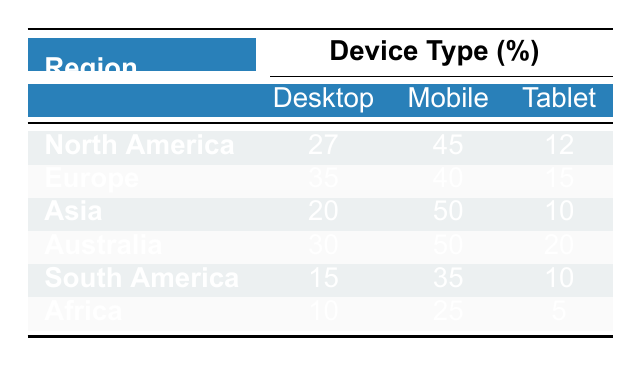What is the percentage of VPN usage for Desktop in Europe? The table shows that the percentage of VPN usage for Desktop in Europe is 35.
Answer: 35 Which region has the highest VPN usage on Mobile devices? By inspecting the table, Asia and Australia both have 50% VPN usage on Mobile devices, which is the highest among all regions.
Answer: Asia and Australia What is the total percentage of VPN usage on Tablets across all regions? Adding the percentages for Tablets from each region gives (12 + 15 + 10 + 20 + 10 + 5) = 72.
Answer: 72 Is South America's VPN usage on Desktop greater than that of Africa? The table indicates that South America has 15% usage on Desktop, while Africa has 10%, meaning South America’s usage is indeed greater.
Answer: Yes What is the difference in VPN usage percentage on Mobile devices between North America and South America? North America has 45% and South America has 35% for Mobile devices. The difference is 45 - 35 = 10.
Answer: 10 What is the average VPN usage percentage for Tablets across all regions? Adding the percentages for Tablets gives (12 + 15 + 10 + 20 + 10 + 5) = 72, and there are 6 regions; thus, the average is 72/6 = 12.
Answer: 12 Which region has the lowest VPN usage on Tablets? By examining the Table for Tablet usage percentages, Africa has the lowest at 5%.
Answer: Africa If you combine the VPN usage percentages for Desktop and Tablet in North America, what is the total? The Desktop percentage is 27% and the Tablet percentage is 12%. Therefore, the total is 27 + 12 = 39.
Answer: 39 How does the VPN usage on Mobile compare between Europe and Asia? Europe has 40% and Asia has 50% on Mobile devices. Therefore, Asia has a higher percentage by 10%.
Answer: Asia has a higher percentage 